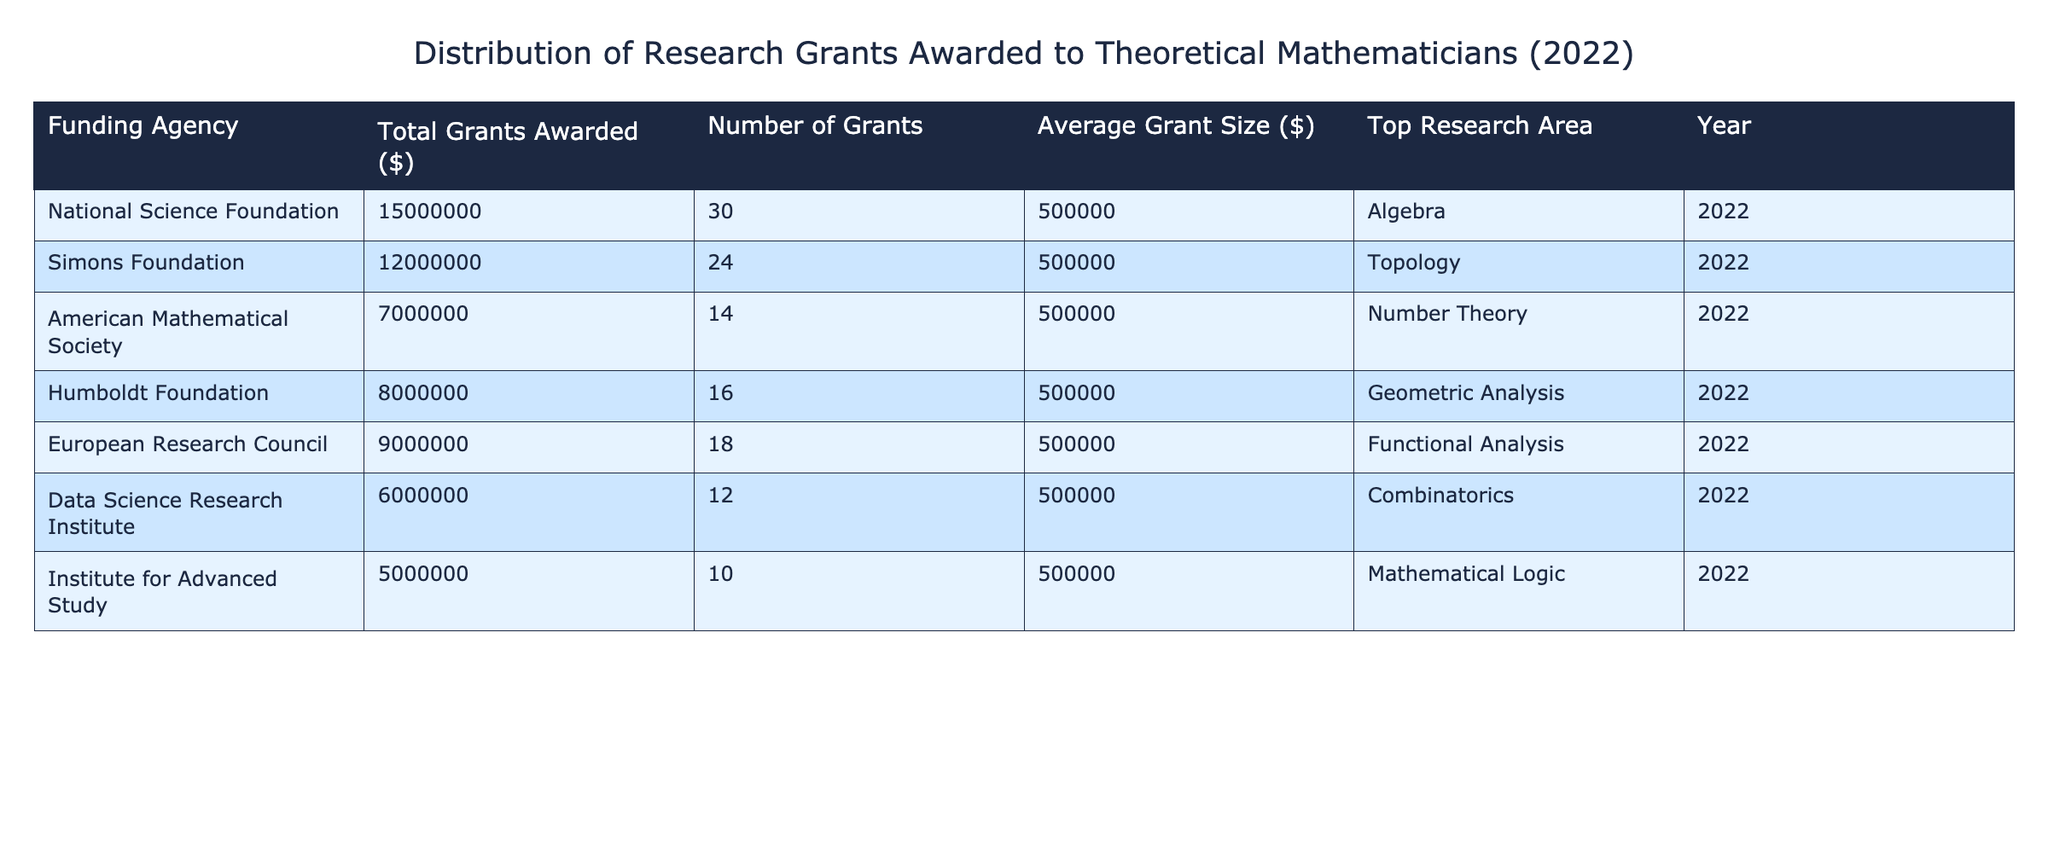What is the top research area funded by the National Science Foundation? The table indicates that the top research area for the National Science Foundation is Algebra. This can be directly observed in the "Top Research Area" column corresponding to the National Science Foundation's row.
Answer: Algebra How many grants were awarded by the Simons Foundation? By looking at the row for the Simons Foundation, we can see that the total number of grants awarded is 24.
Answer: 24 What is the average grant size awarded across all funding agencies? The average grant size for all funding agencies is consistent at $500,000, as seen in every row of the "Average Grant Size" column. Since all values are the same, this simplifies our calculation.
Answer: 500000 Which funding agency awarded the least total grant amount? The funding agency that awarded the least total amount is the Institute for Advanced Study, with a total grant awarded of $5,000,000, as stated in the "Total Grants Awarded" column.
Answer: Institute for Advanced Study What is the difference in total grants awarded between the American Mathematical Society and the European Research Council? The total grants awarded to the American Mathematical Society is $7,000,000 and to the European Research Council is $9,000,000. To find the difference, we subtract $7,000,000 from $9,000,000, resulting in a difference of $2,000,000.
Answer: 2000000 Is the top research area for the Humboldt Foundation Geometric Analysis? Referring to the "Top Research Area" column for the Humboldt Foundation, we find it is indeed Geometric Analysis, confirming that the statement is true.
Answer: Yes What is the sum of total grants awarded by the Data Science Research Institute and the Institute for Advanced Study? The total grants awarded by the Data Science Research Institute is $6,000,000 and by the Institute for Advanced Study is $5,000,000. Adding these together ($6,000,000 + $5,000,000) gives a total of $11,000,000.
Answer: 11000000 Which funding agency had a total grant award of $8,000,000? By examining the total grants awarded column, we can see that the Humboldt Foundation had a total grant award of $8,000,000. This matches the criteria specified in the question.
Answer: Humboldt Foundation Is the average grant size different among the funding agencies? No, the average grant size is consistent at $500,000 for each funding agency according to the "Average Grant Size" column, indicating no variability across the agencies.
Answer: No 